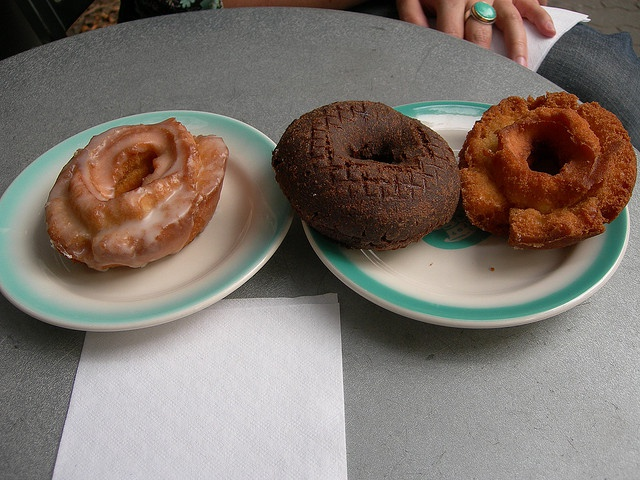Describe the objects in this image and their specific colors. I can see dining table in gray, darkgray, lightgray, and black tones, donut in black, brown, and maroon tones, donut in black, maroon, and brown tones, donut in black, maroon, and brown tones, and people in black, gray, maroon, and brown tones in this image. 